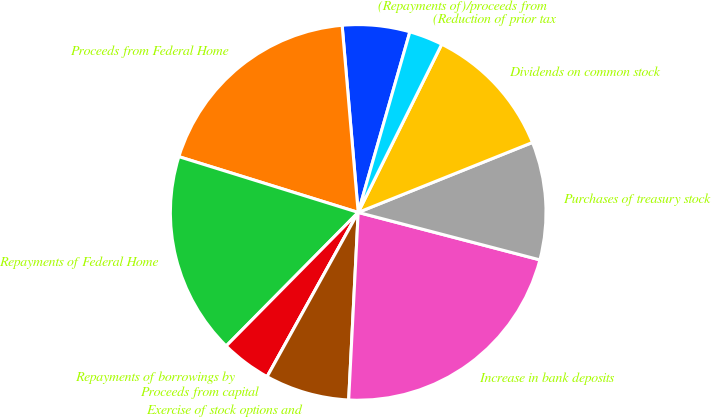<chart> <loc_0><loc_0><loc_500><loc_500><pie_chart><fcel>(Repayments of)/proceeds from<fcel>Proceeds from Federal Home<fcel>Repayments of Federal Home<fcel>Repayments of borrowings by<fcel>Proceeds from capital<fcel>Exercise of stock options and<fcel>Increase in bank deposits<fcel>Purchases of treasury stock<fcel>Dividends on common stock<fcel>(Reduction of prior tax<nl><fcel>5.8%<fcel>18.84%<fcel>17.39%<fcel>4.35%<fcel>0.0%<fcel>7.25%<fcel>21.74%<fcel>10.14%<fcel>11.59%<fcel>2.9%<nl></chart> 